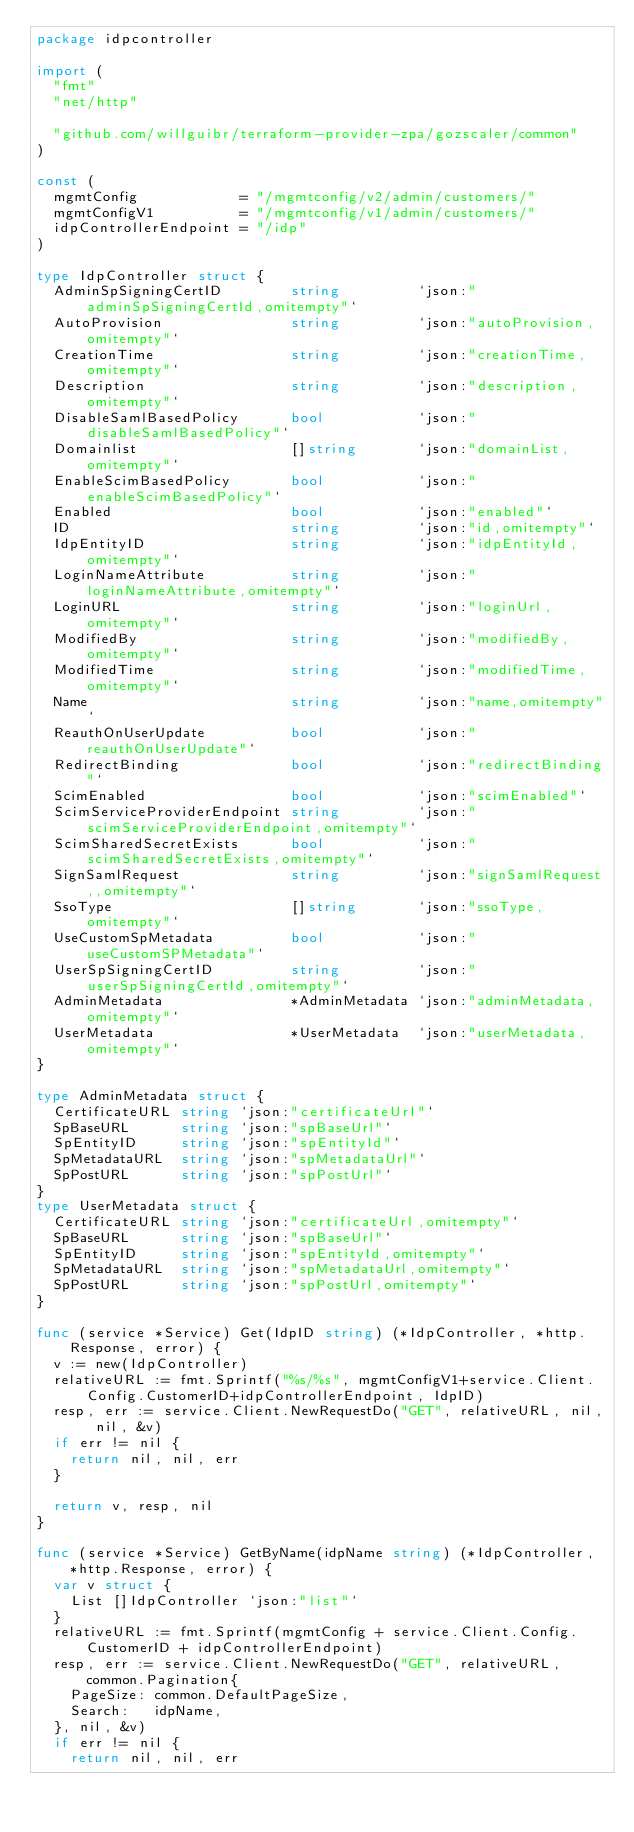<code> <loc_0><loc_0><loc_500><loc_500><_Go_>package idpcontroller

import (
	"fmt"
	"net/http"

	"github.com/willguibr/terraform-provider-zpa/gozscaler/common"
)

const (
	mgmtConfig            = "/mgmtconfig/v2/admin/customers/"
	mgmtConfigV1          = "/mgmtconfig/v1/admin/customers/"
	idpControllerEndpoint = "/idp"
)

type IdpController struct {
	AdminSpSigningCertID        string         `json:"adminSpSigningCertId,omitempty"`
	AutoProvision               string         `json:"autoProvision,omitempty"`
	CreationTime                string         `json:"creationTime,omitempty"`
	Description                 string         `json:"description,omitempty"`
	DisableSamlBasedPolicy      bool           `json:"disableSamlBasedPolicy"`
	Domainlist                  []string       `json:"domainList,omitempty"`
	EnableScimBasedPolicy       bool           `json:"enableScimBasedPolicy"`
	Enabled                     bool           `json:"enabled"`
	ID                          string         `json:"id,omitempty"`
	IdpEntityID                 string         `json:"idpEntityId,omitempty"`
	LoginNameAttribute          string         `json:"loginNameAttribute,omitempty"`
	LoginURL                    string         `json:"loginUrl,omitempty"`
	ModifiedBy                  string         `json:"modifiedBy,omitempty"`
	ModifiedTime                string         `json:"modifiedTime,omitempty"`
	Name                        string         `json:"name,omitempty"`
	ReauthOnUserUpdate          bool           `json:"reauthOnUserUpdate"`
	RedirectBinding             bool           `json:"redirectBinding"`
	ScimEnabled                 bool           `json:"scimEnabled"`
	ScimServiceProviderEndpoint string         `json:"scimServiceProviderEndpoint,omitempty"`
	ScimSharedSecretExists      bool           `json:"scimSharedSecretExists,omitempty"`
	SignSamlRequest             string         `json:"signSamlRequest,,omitempty"`
	SsoType                     []string       `json:"ssoType,omitempty"`
	UseCustomSpMetadata         bool           `json:"useCustomSPMetadata"`
	UserSpSigningCertID         string         `json:"userSpSigningCertId,omitempty"`
	AdminMetadata               *AdminMetadata `json:"adminMetadata,omitempty"`
	UserMetadata                *UserMetadata  `json:"userMetadata,omitempty"`
}

type AdminMetadata struct {
	CertificateURL string `json:"certificateUrl"`
	SpBaseURL      string `json:"spBaseUrl"`
	SpEntityID     string `json:"spEntityId"`
	SpMetadataURL  string `json:"spMetadataUrl"`
	SpPostURL      string `json:"spPostUrl"`
}
type UserMetadata struct {
	CertificateURL string `json:"certificateUrl,omitempty"`
	SpBaseURL      string `json:"spBaseUrl"`
	SpEntityID     string `json:"spEntityId,omitempty"`
	SpMetadataURL  string `json:"spMetadataUrl,omitempty"`
	SpPostURL      string `json:"spPostUrl,omitempty"`
}

func (service *Service) Get(IdpID string) (*IdpController, *http.Response, error) {
	v := new(IdpController)
	relativeURL := fmt.Sprintf("%s/%s", mgmtConfigV1+service.Client.Config.CustomerID+idpControllerEndpoint, IdpID)
	resp, err := service.Client.NewRequestDo("GET", relativeURL, nil, nil, &v)
	if err != nil {
		return nil, nil, err
	}

	return v, resp, nil
}

func (service *Service) GetByName(idpName string) (*IdpController, *http.Response, error) {
	var v struct {
		List []IdpController `json:"list"`
	}
	relativeURL := fmt.Sprintf(mgmtConfig + service.Client.Config.CustomerID + idpControllerEndpoint)
	resp, err := service.Client.NewRequestDo("GET", relativeURL, common.Pagination{
		PageSize: common.DefaultPageSize,
		Search:   idpName,
	}, nil, &v)
	if err != nil {
		return nil, nil, err</code> 